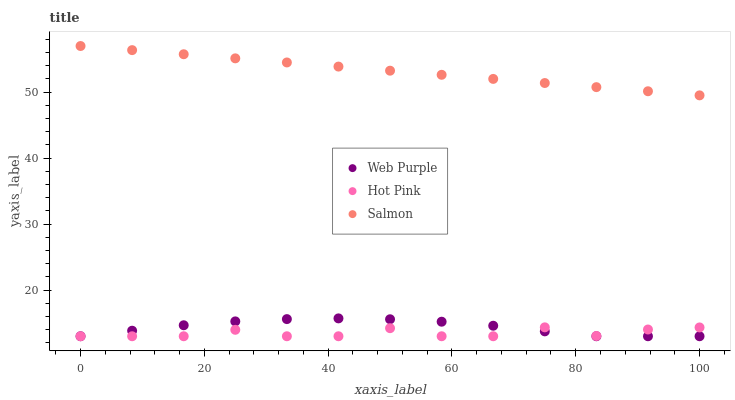Does Hot Pink have the minimum area under the curve?
Answer yes or no. Yes. Does Salmon have the maximum area under the curve?
Answer yes or no. Yes. Does Salmon have the minimum area under the curve?
Answer yes or no. No. Does Hot Pink have the maximum area under the curve?
Answer yes or no. No. Is Salmon the smoothest?
Answer yes or no. Yes. Is Hot Pink the roughest?
Answer yes or no. Yes. Is Hot Pink the smoothest?
Answer yes or no. No. Is Salmon the roughest?
Answer yes or no. No. Does Web Purple have the lowest value?
Answer yes or no. Yes. Does Salmon have the lowest value?
Answer yes or no. No. Does Salmon have the highest value?
Answer yes or no. Yes. Does Hot Pink have the highest value?
Answer yes or no. No. Is Web Purple less than Salmon?
Answer yes or no. Yes. Is Salmon greater than Web Purple?
Answer yes or no. Yes. Does Web Purple intersect Hot Pink?
Answer yes or no. Yes. Is Web Purple less than Hot Pink?
Answer yes or no. No. Is Web Purple greater than Hot Pink?
Answer yes or no. No. Does Web Purple intersect Salmon?
Answer yes or no. No. 